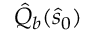Convert formula to latex. <formula><loc_0><loc_0><loc_500><loc_500>\hat { Q } _ { b } ( \hat { s } _ { 0 } )</formula> 